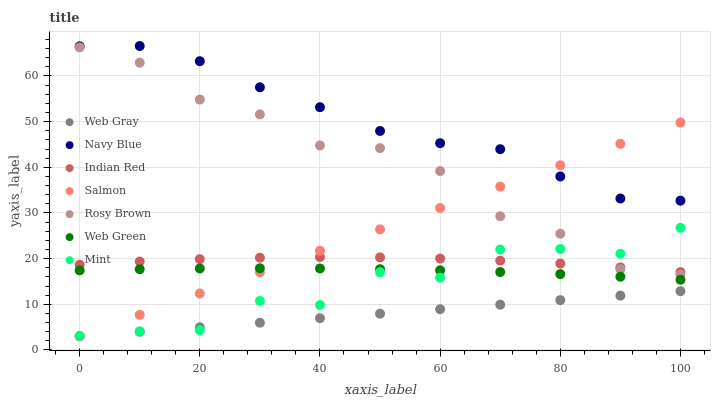Does Web Gray have the minimum area under the curve?
Answer yes or no. Yes. Does Navy Blue have the maximum area under the curve?
Answer yes or no. Yes. Does Rosy Brown have the minimum area under the curve?
Answer yes or no. No. Does Rosy Brown have the maximum area under the curve?
Answer yes or no. No. Is Web Gray the smoothest?
Answer yes or no. Yes. Is Mint the roughest?
Answer yes or no. Yes. Is Navy Blue the smoothest?
Answer yes or no. No. Is Navy Blue the roughest?
Answer yes or no. No. Does Web Gray have the lowest value?
Answer yes or no. Yes. Does Rosy Brown have the lowest value?
Answer yes or no. No. Does Navy Blue have the highest value?
Answer yes or no. Yes. Does Rosy Brown have the highest value?
Answer yes or no. No. Is Web Gray less than Navy Blue?
Answer yes or no. Yes. Is Indian Red greater than Web Green?
Answer yes or no. Yes. Does Rosy Brown intersect Mint?
Answer yes or no. Yes. Is Rosy Brown less than Mint?
Answer yes or no. No. Is Rosy Brown greater than Mint?
Answer yes or no. No. Does Web Gray intersect Navy Blue?
Answer yes or no. No. 